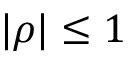Convert formula to latex. <formula><loc_0><loc_0><loc_500><loc_500>| \rho | \leq 1</formula> 